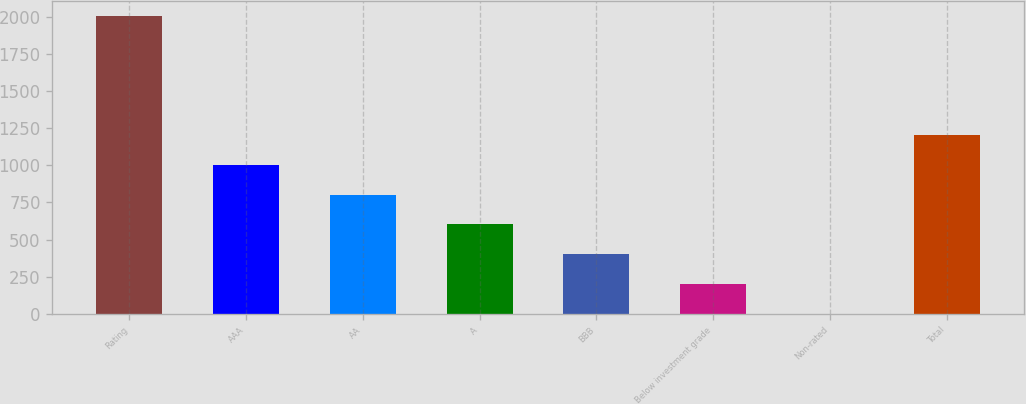Convert chart. <chart><loc_0><loc_0><loc_500><loc_500><bar_chart><fcel>Rating<fcel>AAA<fcel>AA<fcel>A<fcel>BBB<fcel>Below investment grade<fcel>Non-rated<fcel>Total<nl><fcel>2006<fcel>1003.5<fcel>803<fcel>602.5<fcel>402<fcel>201.5<fcel>1<fcel>1204<nl></chart> 